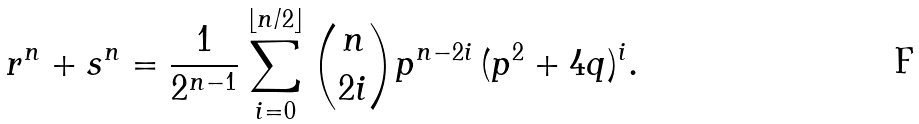Convert formula to latex. <formula><loc_0><loc_0><loc_500><loc_500>r ^ { n } + s ^ { n } = \frac { 1 } { 2 ^ { n - 1 } } \sum _ { i = 0 } ^ { \lfloor n / 2 \rfloor } \binom { n } { 2 i } p ^ { n - 2 i } \, ( p ^ { 2 } + 4 q ) ^ { i } .</formula> 